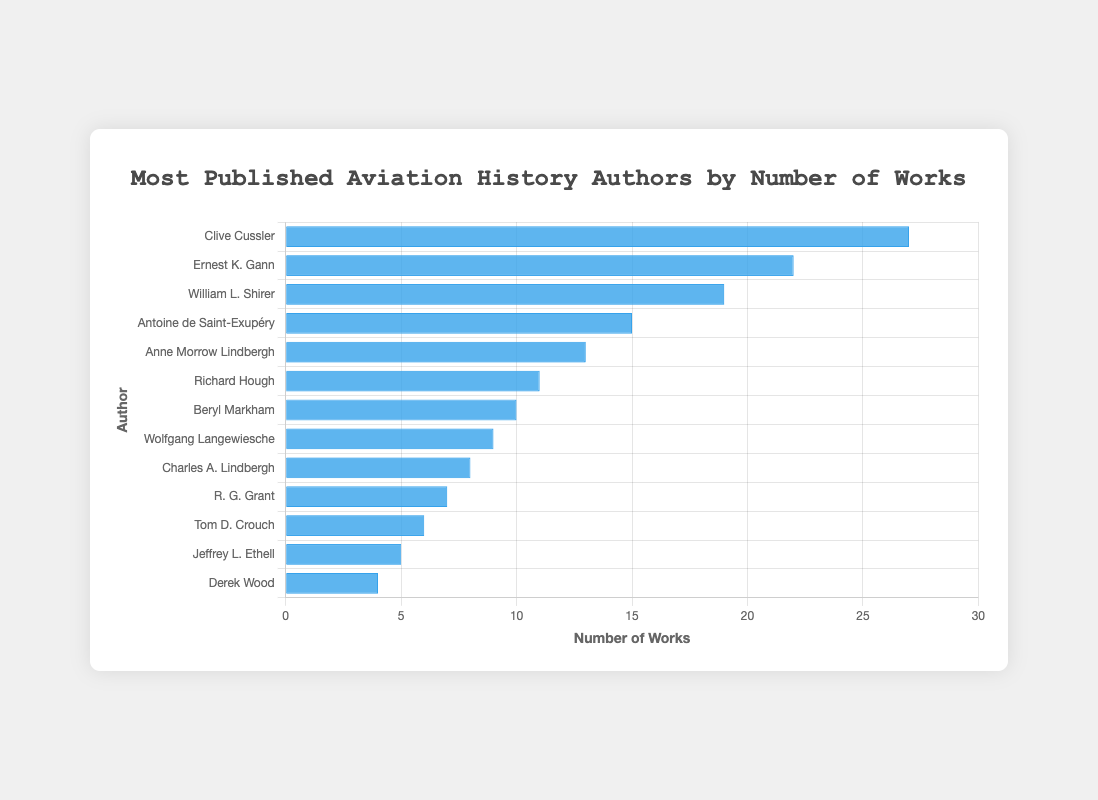What is the title of the figure? The title of the figure is shown at the top and it reads "Most Published Aviation History Authors by Number of Works"
Answer: Most Published Aviation History Authors by Number of Works Which author has published the highest number of works? By looking at the horizontal bars, it is clear that Clive Cussler has the longest bar, indicating he has published the highest number of works.
Answer: Clive Cussler Which author has published the fewest works in the given dataset? The shortest bar on the chart corresponds to Derek Wood, indicating he has published the fewest works.
Answer: Derek Wood How many more works has Clive Cussler published compared to Antoine de Saint-Exupéry? Clive Cussler has published 27 works and Antoine de Saint-Exupéry has published 15. The difference is 27 - 15 = 12 works.
Answer: 12 What is the average number of works published by these authors? To find the average, sum the number of works (27+22+19+15+13+11+10+9+8+7+6+5+4 = 156) and divide by the number of authors (13). The average is 156 / 13 = 12 works.
Answer: 12 Which author has published just one more work than Anne Morrow Lindbergh? Anne Morrow Lindbergh has published 13 works. Next, we check for the author with 14 works. There is no author with 14 works; only Richard Hough comes close with 11.
Answer: No author with just one more What is the combined number of works published by Clive Cussler and Ernest K. Gann? The number of works published by Clive Cussler is 27 and by Ernest K. Gann is 22. Their combined total is 27 + 22 = 49 works.
Answer: 49 Is there a significant visual gap between any two authors in the number of publications? Visually examining the chart, the largest gap appears between Clive Cussler (27 works) and Ernest K. Gann (22 works). The gap is clearly wider than between any other consecutive pairs.
Answer: Yes, between Clive Cussler and Ernest K. Gann How many authors have published more works than Charles A. Lindbergh? Charles A. Lindbergh has published 8 works. Counting the authors who published more, we get Clive Cussler, Ernest K. Gann, William L. Shirer, Antoine de Saint-Exupéry, Anne Morrow Lindbergh, Richard Hough, Beryl Markham, and Wolfgang Langewiesche, totaling 8 authors.
Answer: 8 What is the total number of works published by the bottom three authors? The bottom three authors are Derek Wood (4), Jeffrey L. Ethell (5), and Tom D. Crouch (6). The total is 4 + 5 + 6 = 15 works.
Answer: 15 